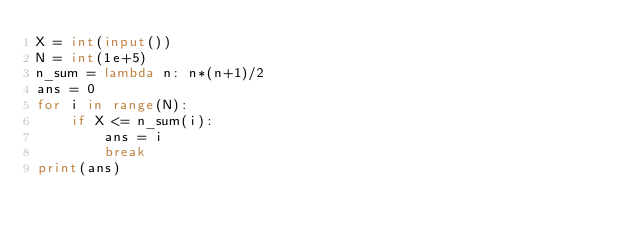Convert code to text. <code><loc_0><loc_0><loc_500><loc_500><_Python_>X = int(input())
N = int(1e+5)
n_sum = lambda n: n*(n+1)/2
ans = 0
for i in range(N):
    if X <= n_sum(i):
        ans = i
        break
print(ans)</code> 